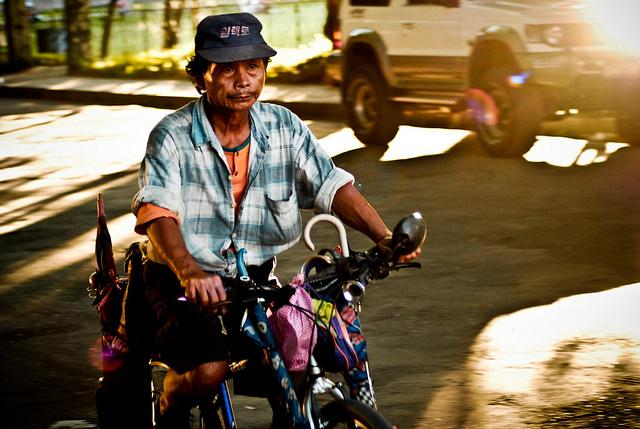Why do they have so many umbrellas? selling them 